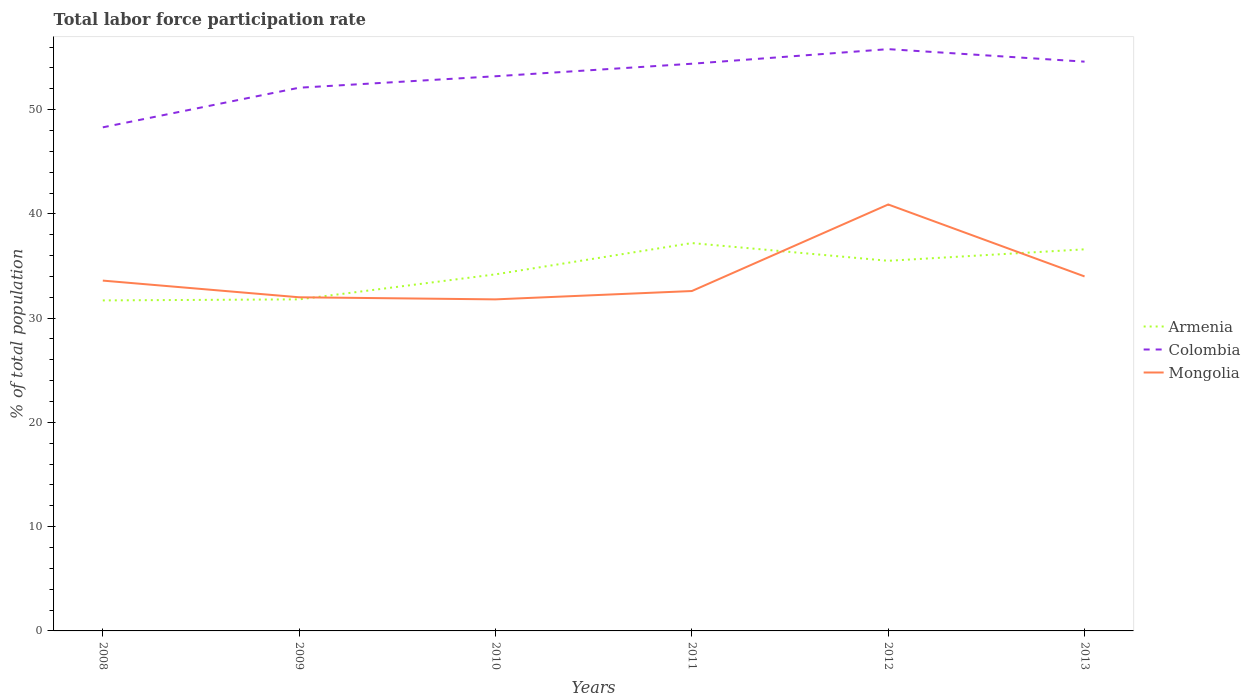How many different coloured lines are there?
Give a very brief answer. 3. Does the line corresponding to Armenia intersect with the line corresponding to Mongolia?
Your response must be concise. Yes. Is the number of lines equal to the number of legend labels?
Your answer should be compact. Yes. Across all years, what is the maximum total labor force participation rate in Colombia?
Give a very brief answer. 48.3. What is the total total labor force participation rate in Colombia in the graph?
Make the answer very short. -0.2. What is the difference between the highest and the second highest total labor force participation rate in Mongolia?
Provide a short and direct response. 9.1. Is the total labor force participation rate in Mongolia strictly greater than the total labor force participation rate in Colombia over the years?
Your response must be concise. Yes. How many years are there in the graph?
Provide a succinct answer. 6. What is the difference between two consecutive major ticks on the Y-axis?
Offer a terse response. 10. Does the graph contain any zero values?
Offer a very short reply. No. Where does the legend appear in the graph?
Your response must be concise. Center right. How many legend labels are there?
Provide a short and direct response. 3. What is the title of the graph?
Provide a succinct answer. Total labor force participation rate. Does "Middle income" appear as one of the legend labels in the graph?
Offer a terse response. No. What is the label or title of the Y-axis?
Offer a terse response. % of total population. What is the % of total population in Armenia in 2008?
Provide a short and direct response. 31.7. What is the % of total population in Colombia in 2008?
Your answer should be compact. 48.3. What is the % of total population in Mongolia in 2008?
Provide a short and direct response. 33.6. What is the % of total population in Armenia in 2009?
Your response must be concise. 31.8. What is the % of total population of Colombia in 2009?
Offer a very short reply. 52.1. What is the % of total population in Mongolia in 2009?
Keep it short and to the point. 32. What is the % of total population in Armenia in 2010?
Keep it short and to the point. 34.2. What is the % of total population in Colombia in 2010?
Your response must be concise. 53.2. What is the % of total population of Mongolia in 2010?
Your answer should be very brief. 31.8. What is the % of total population of Armenia in 2011?
Your response must be concise. 37.2. What is the % of total population of Colombia in 2011?
Ensure brevity in your answer.  54.4. What is the % of total population of Mongolia in 2011?
Your answer should be compact. 32.6. What is the % of total population in Armenia in 2012?
Keep it short and to the point. 35.5. What is the % of total population of Colombia in 2012?
Keep it short and to the point. 55.8. What is the % of total population of Mongolia in 2012?
Offer a terse response. 40.9. What is the % of total population of Armenia in 2013?
Provide a short and direct response. 36.6. What is the % of total population of Colombia in 2013?
Make the answer very short. 54.6. Across all years, what is the maximum % of total population of Armenia?
Give a very brief answer. 37.2. Across all years, what is the maximum % of total population of Colombia?
Make the answer very short. 55.8. Across all years, what is the maximum % of total population of Mongolia?
Make the answer very short. 40.9. Across all years, what is the minimum % of total population in Armenia?
Provide a short and direct response. 31.7. Across all years, what is the minimum % of total population of Colombia?
Keep it short and to the point. 48.3. Across all years, what is the minimum % of total population of Mongolia?
Ensure brevity in your answer.  31.8. What is the total % of total population of Armenia in the graph?
Make the answer very short. 207. What is the total % of total population of Colombia in the graph?
Your response must be concise. 318.4. What is the total % of total population in Mongolia in the graph?
Give a very brief answer. 204.9. What is the difference between the % of total population of Mongolia in 2008 and that in 2009?
Make the answer very short. 1.6. What is the difference between the % of total population of Mongolia in 2008 and that in 2010?
Provide a succinct answer. 1.8. What is the difference between the % of total population in Armenia in 2008 and that in 2011?
Provide a succinct answer. -5.5. What is the difference between the % of total population of Colombia in 2008 and that in 2011?
Offer a very short reply. -6.1. What is the difference between the % of total population in Armenia in 2008 and that in 2012?
Your answer should be compact. -3.8. What is the difference between the % of total population of Mongolia in 2008 and that in 2012?
Your answer should be compact. -7.3. What is the difference between the % of total population in Colombia in 2008 and that in 2013?
Give a very brief answer. -6.3. What is the difference between the % of total population of Mongolia in 2008 and that in 2013?
Your answer should be compact. -0.4. What is the difference between the % of total population of Mongolia in 2009 and that in 2011?
Provide a succinct answer. -0.6. What is the difference between the % of total population in Colombia in 2009 and that in 2012?
Ensure brevity in your answer.  -3.7. What is the difference between the % of total population in Mongolia in 2009 and that in 2012?
Provide a short and direct response. -8.9. What is the difference between the % of total population of Colombia in 2010 and that in 2011?
Your answer should be very brief. -1.2. What is the difference between the % of total population in Colombia in 2010 and that in 2012?
Offer a terse response. -2.6. What is the difference between the % of total population of Mongolia in 2010 and that in 2012?
Offer a very short reply. -9.1. What is the difference between the % of total population of Armenia in 2010 and that in 2013?
Provide a short and direct response. -2.4. What is the difference between the % of total population in Mongolia in 2010 and that in 2013?
Provide a succinct answer. -2.2. What is the difference between the % of total population of Colombia in 2011 and that in 2013?
Provide a short and direct response. -0.2. What is the difference between the % of total population in Armenia in 2012 and that in 2013?
Your answer should be compact. -1.1. What is the difference between the % of total population in Colombia in 2012 and that in 2013?
Your answer should be compact. 1.2. What is the difference between the % of total population in Mongolia in 2012 and that in 2013?
Your response must be concise. 6.9. What is the difference between the % of total population in Armenia in 2008 and the % of total population in Colombia in 2009?
Keep it short and to the point. -20.4. What is the difference between the % of total population in Colombia in 2008 and the % of total population in Mongolia in 2009?
Offer a very short reply. 16.3. What is the difference between the % of total population in Armenia in 2008 and the % of total population in Colombia in 2010?
Provide a succinct answer. -21.5. What is the difference between the % of total population of Armenia in 2008 and the % of total population of Mongolia in 2010?
Your answer should be very brief. -0.1. What is the difference between the % of total population in Colombia in 2008 and the % of total population in Mongolia in 2010?
Give a very brief answer. 16.5. What is the difference between the % of total population in Armenia in 2008 and the % of total population in Colombia in 2011?
Your answer should be very brief. -22.7. What is the difference between the % of total population in Colombia in 2008 and the % of total population in Mongolia in 2011?
Give a very brief answer. 15.7. What is the difference between the % of total population of Armenia in 2008 and the % of total population of Colombia in 2012?
Offer a terse response. -24.1. What is the difference between the % of total population of Armenia in 2008 and the % of total population of Mongolia in 2012?
Provide a succinct answer. -9.2. What is the difference between the % of total population of Armenia in 2008 and the % of total population of Colombia in 2013?
Offer a very short reply. -22.9. What is the difference between the % of total population in Colombia in 2008 and the % of total population in Mongolia in 2013?
Provide a succinct answer. 14.3. What is the difference between the % of total population in Armenia in 2009 and the % of total population in Colombia in 2010?
Ensure brevity in your answer.  -21.4. What is the difference between the % of total population of Armenia in 2009 and the % of total population of Mongolia in 2010?
Your answer should be compact. 0. What is the difference between the % of total population in Colombia in 2009 and the % of total population in Mongolia in 2010?
Offer a terse response. 20.3. What is the difference between the % of total population in Armenia in 2009 and the % of total population in Colombia in 2011?
Provide a succinct answer. -22.6. What is the difference between the % of total population of Armenia in 2009 and the % of total population of Colombia in 2013?
Give a very brief answer. -22.8. What is the difference between the % of total population in Colombia in 2009 and the % of total population in Mongolia in 2013?
Offer a terse response. 18.1. What is the difference between the % of total population of Armenia in 2010 and the % of total population of Colombia in 2011?
Offer a terse response. -20.2. What is the difference between the % of total population of Armenia in 2010 and the % of total population of Mongolia in 2011?
Keep it short and to the point. 1.6. What is the difference between the % of total population of Colombia in 2010 and the % of total population of Mongolia in 2011?
Keep it short and to the point. 20.6. What is the difference between the % of total population of Armenia in 2010 and the % of total population of Colombia in 2012?
Give a very brief answer. -21.6. What is the difference between the % of total population of Colombia in 2010 and the % of total population of Mongolia in 2012?
Keep it short and to the point. 12.3. What is the difference between the % of total population of Armenia in 2010 and the % of total population of Colombia in 2013?
Ensure brevity in your answer.  -20.4. What is the difference between the % of total population of Armenia in 2010 and the % of total population of Mongolia in 2013?
Offer a terse response. 0.2. What is the difference between the % of total population in Armenia in 2011 and the % of total population in Colombia in 2012?
Offer a terse response. -18.6. What is the difference between the % of total population of Armenia in 2011 and the % of total population of Mongolia in 2012?
Make the answer very short. -3.7. What is the difference between the % of total population of Colombia in 2011 and the % of total population of Mongolia in 2012?
Your answer should be very brief. 13.5. What is the difference between the % of total population in Armenia in 2011 and the % of total population in Colombia in 2013?
Provide a succinct answer. -17.4. What is the difference between the % of total population of Colombia in 2011 and the % of total population of Mongolia in 2013?
Provide a succinct answer. 20.4. What is the difference between the % of total population in Armenia in 2012 and the % of total population in Colombia in 2013?
Keep it short and to the point. -19.1. What is the difference between the % of total population of Armenia in 2012 and the % of total population of Mongolia in 2013?
Your answer should be very brief. 1.5. What is the difference between the % of total population of Colombia in 2012 and the % of total population of Mongolia in 2013?
Ensure brevity in your answer.  21.8. What is the average % of total population in Armenia per year?
Provide a short and direct response. 34.5. What is the average % of total population of Colombia per year?
Offer a very short reply. 53.07. What is the average % of total population of Mongolia per year?
Your answer should be very brief. 34.15. In the year 2008, what is the difference between the % of total population of Armenia and % of total population of Colombia?
Make the answer very short. -16.6. In the year 2008, what is the difference between the % of total population of Armenia and % of total population of Mongolia?
Your answer should be very brief. -1.9. In the year 2009, what is the difference between the % of total population of Armenia and % of total population of Colombia?
Ensure brevity in your answer.  -20.3. In the year 2009, what is the difference between the % of total population of Colombia and % of total population of Mongolia?
Provide a succinct answer. 20.1. In the year 2010, what is the difference between the % of total population of Armenia and % of total population of Colombia?
Your response must be concise. -19. In the year 2010, what is the difference between the % of total population in Armenia and % of total population in Mongolia?
Your response must be concise. 2.4. In the year 2010, what is the difference between the % of total population in Colombia and % of total population in Mongolia?
Your answer should be very brief. 21.4. In the year 2011, what is the difference between the % of total population of Armenia and % of total population of Colombia?
Keep it short and to the point. -17.2. In the year 2011, what is the difference between the % of total population in Armenia and % of total population in Mongolia?
Offer a very short reply. 4.6. In the year 2011, what is the difference between the % of total population of Colombia and % of total population of Mongolia?
Offer a terse response. 21.8. In the year 2012, what is the difference between the % of total population of Armenia and % of total population of Colombia?
Keep it short and to the point. -20.3. In the year 2012, what is the difference between the % of total population in Armenia and % of total population in Mongolia?
Provide a short and direct response. -5.4. In the year 2013, what is the difference between the % of total population in Colombia and % of total population in Mongolia?
Keep it short and to the point. 20.6. What is the ratio of the % of total population of Armenia in 2008 to that in 2009?
Your answer should be very brief. 1. What is the ratio of the % of total population of Colombia in 2008 to that in 2009?
Keep it short and to the point. 0.93. What is the ratio of the % of total population in Mongolia in 2008 to that in 2009?
Your answer should be very brief. 1.05. What is the ratio of the % of total population in Armenia in 2008 to that in 2010?
Ensure brevity in your answer.  0.93. What is the ratio of the % of total population of Colombia in 2008 to that in 2010?
Provide a succinct answer. 0.91. What is the ratio of the % of total population of Mongolia in 2008 to that in 2010?
Offer a terse response. 1.06. What is the ratio of the % of total population in Armenia in 2008 to that in 2011?
Give a very brief answer. 0.85. What is the ratio of the % of total population of Colombia in 2008 to that in 2011?
Give a very brief answer. 0.89. What is the ratio of the % of total population in Mongolia in 2008 to that in 2011?
Offer a terse response. 1.03. What is the ratio of the % of total population in Armenia in 2008 to that in 2012?
Provide a succinct answer. 0.89. What is the ratio of the % of total population of Colombia in 2008 to that in 2012?
Make the answer very short. 0.87. What is the ratio of the % of total population in Mongolia in 2008 to that in 2012?
Offer a terse response. 0.82. What is the ratio of the % of total population in Armenia in 2008 to that in 2013?
Your answer should be compact. 0.87. What is the ratio of the % of total population of Colombia in 2008 to that in 2013?
Your answer should be compact. 0.88. What is the ratio of the % of total population of Mongolia in 2008 to that in 2013?
Give a very brief answer. 0.99. What is the ratio of the % of total population in Armenia in 2009 to that in 2010?
Ensure brevity in your answer.  0.93. What is the ratio of the % of total population of Colombia in 2009 to that in 2010?
Your answer should be compact. 0.98. What is the ratio of the % of total population of Mongolia in 2009 to that in 2010?
Provide a short and direct response. 1.01. What is the ratio of the % of total population of Armenia in 2009 to that in 2011?
Your answer should be compact. 0.85. What is the ratio of the % of total population in Colombia in 2009 to that in 2011?
Offer a very short reply. 0.96. What is the ratio of the % of total population in Mongolia in 2009 to that in 2011?
Your answer should be very brief. 0.98. What is the ratio of the % of total population of Armenia in 2009 to that in 2012?
Give a very brief answer. 0.9. What is the ratio of the % of total population in Colombia in 2009 to that in 2012?
Provide a succinct answer. 0.93. What is the ratio of the % of total population of Mongolia in 2009 to that in 2012?
Your answer should be compact. 0.78. What is the ratio of the % of total population of Armenia in 2009 to that in 2013?
Provide a short and direct response. 0.87. What is the ratio of the % of total population of Colombia in 2009 to that in 2013?
Ensure brevity in your answer.  0.95. What is the ratio of the % of total population in Armenia in 2010 to that in 2011?
Your answer should be compact. 0.92. What is the ratio of the % of total population of Colombia in 2010 to that in 2011?
Offer a terse response. 0.98. What is the ratio of the % of total population in Mongolia in 2010 to that in 2011?
Offer a very short reply. 0.98. What is the ratio of the % of total population of Armenia in 2010 to that in 2012?
Ensure brevity in your answer.  0.96. What is the ratio of the % of total population of Colombia in 2010 to that in 2012?
Ensure brevity in your answer.  0.95. What is the ratio of the % of total population of Mongolia in 2010 to that in 2012?
Offer a very short reply. 0.78. What is the ratio of the % of total population of Armenia in 2010 to that in 2013?
Provide a short and direct response. 0.93. What is the ratio of the % of total population in Colombia in 2010 to that in 2013?
Offer a terse response. 0.97. What is the ratio of the % of total population of Mongolia in 2010 to that in 2013?
Make the answer very short. 0.94. What is the ratio of the % of total population of Armenia in 2011 to that in 2012?
Keep it short and to the point. 1.05. What is the ratio of the % of total population of Colombia in 2011 to that in 2012?
Make the answer very short. 0.97. What is the ratio of the % of total population in Mongolia in 2011 to that in 2012?
Make the answer very short. 0.8. What is the ratio of the % of total population of Armenia in 2011 to that in 2013?
Offer a terse response. 1.02. What is the ratio of the % of total population of Colombia in 2011 to that in 2013?
Offer a terse response. 1. What is the ratio of the % of total population in Mongolia in 2011 to that in 2013?
Give a very brief answer. 0.96. What is the ratio of the % of total population of Armenia in 2012 to that in 2013?
Ensure brevity in your answer.  0.97. What is the ratio of the % of total population of Colombia in 2012 to that in 2013?
Make the answer very short. 1.02. What is the ratio of the % of total population of Mongolia in 2012 to that in 2013?
Your answer should be compact. 1.2. What is the difference between the highest and the second highest % of total population in Mongolia?
Offer a terse response. 6.9. What is the difference between the highest and the lowest % of total population in Colombia?
Ensure brevity in your answer.  7.5. What is the difference between the highest and the lowest % of total population in Mongolia?
Your response must be concise. 9.1. 